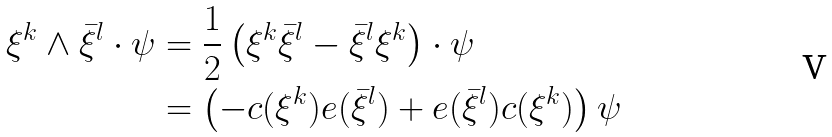<formula> <loc_0><loc_0><loc_500><loc_500>\xi ^ { k } \wedge \bar { \xi } ^ { l } \cdot \psi & = \frac { 1 } { 2 } \left ( \xi ^ { k } \bar { \xi } ^ { l } - \bar { \xi } ^ { l } \xi ^ { k } \right ) \cdot \psi \\ & = \left ( - c ( \xi ^ { k } ) e ( \bar { \xi } ^ { l } ) + e ( \bar { \xi } ^ { l } ) c ( \xi ^ { k } ) \right ) \psi</formula> 